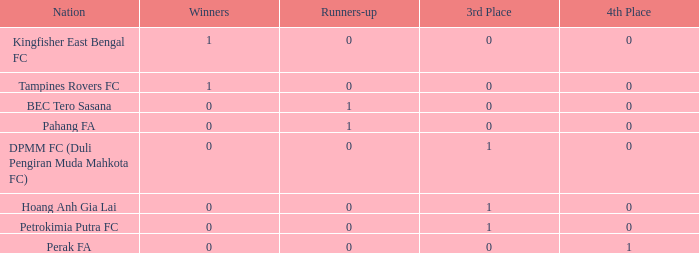Name the highest 3rd place for nation of perak fa 0.0. Give me the full table as a dictionary. {'header': ['Nation', 'Winners', 'Runners-up', '3rd Place', '4th Place'], 'rows': [['Kingfisher East Bengal FC', '1', '0', '0', '0'], ['Tampines Rovers FC', '1', '0', '0', '0'], ['BEC Tero Sasana', '0', '1', '0', '0'], ['Pahang FA', '0', '1', '0', '0'], ['DPMM FC (Duli Pengiran Muda Mahkota FC)', '0', '0', '1', '0'], ['Hoang Anh Gia Lai', '0', '0', '1', '0'], ['Petrokimia Putra FC', '0', '0', '1', '0'], ['Perak FA', '0', '0', '0', '1']]} 